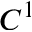Convert formula to latex. <formula><loc_0><loc_0><loc_500><loc_500>C ^ { 1 }</formula> 